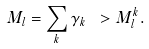Convert formula to latex. <formula><loc_0><loc_0><loc_500><loc_500>M _ { l } = \sum _ { k } \gamma _ { k } \ > M ^ { k } _ { l } .</formula> 